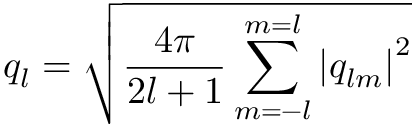Convert formula to latex. <formula><loc_0><loc_0><loc_500><loc_500>q _ { l } = \sqrt { \frac { 4 \pi } { 2 l + 1 } \sum _ { m = - l } ^ { m = l } \left | q _ { l m } \right | ^ { 2 } }</formula> 